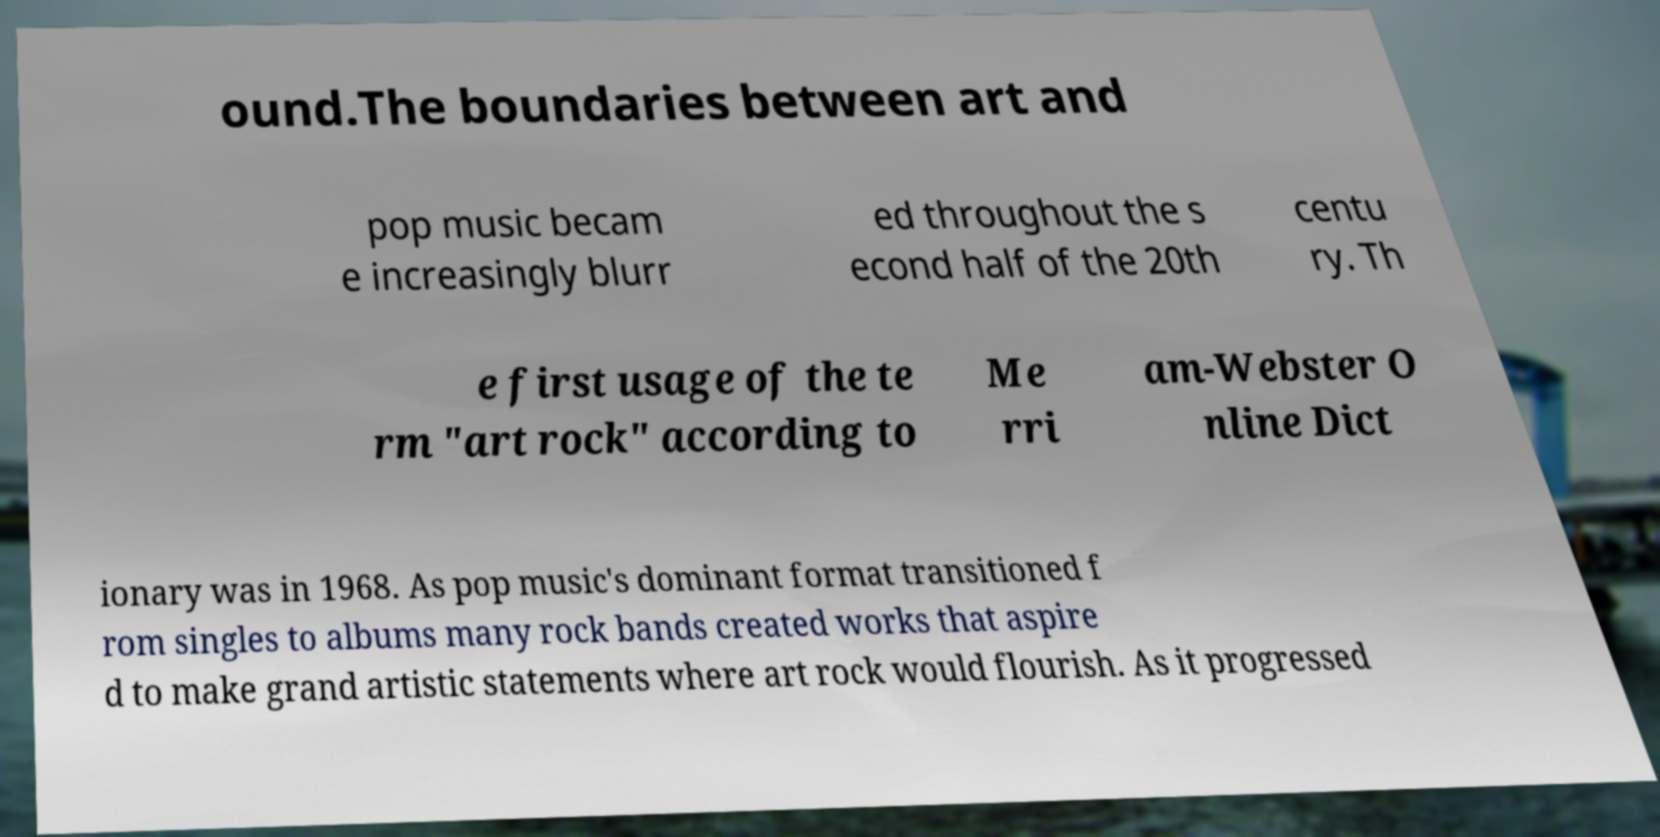Could you assist in decoding the text presented in this image and type it out clearly? ound.The boundaries between art and pop music becam e increasingly blurr ed throughout the s econd half of the 20th centu ry. Th e first usage of the te rm "art rock" according to Me rri am-Webster O nline Dict ionary was in 1968. As pop music's dominant format transitioned f rom singles to albums many rock bands created works that aspire d to make grand artistic statements where art rock would flourish. As it progressed 